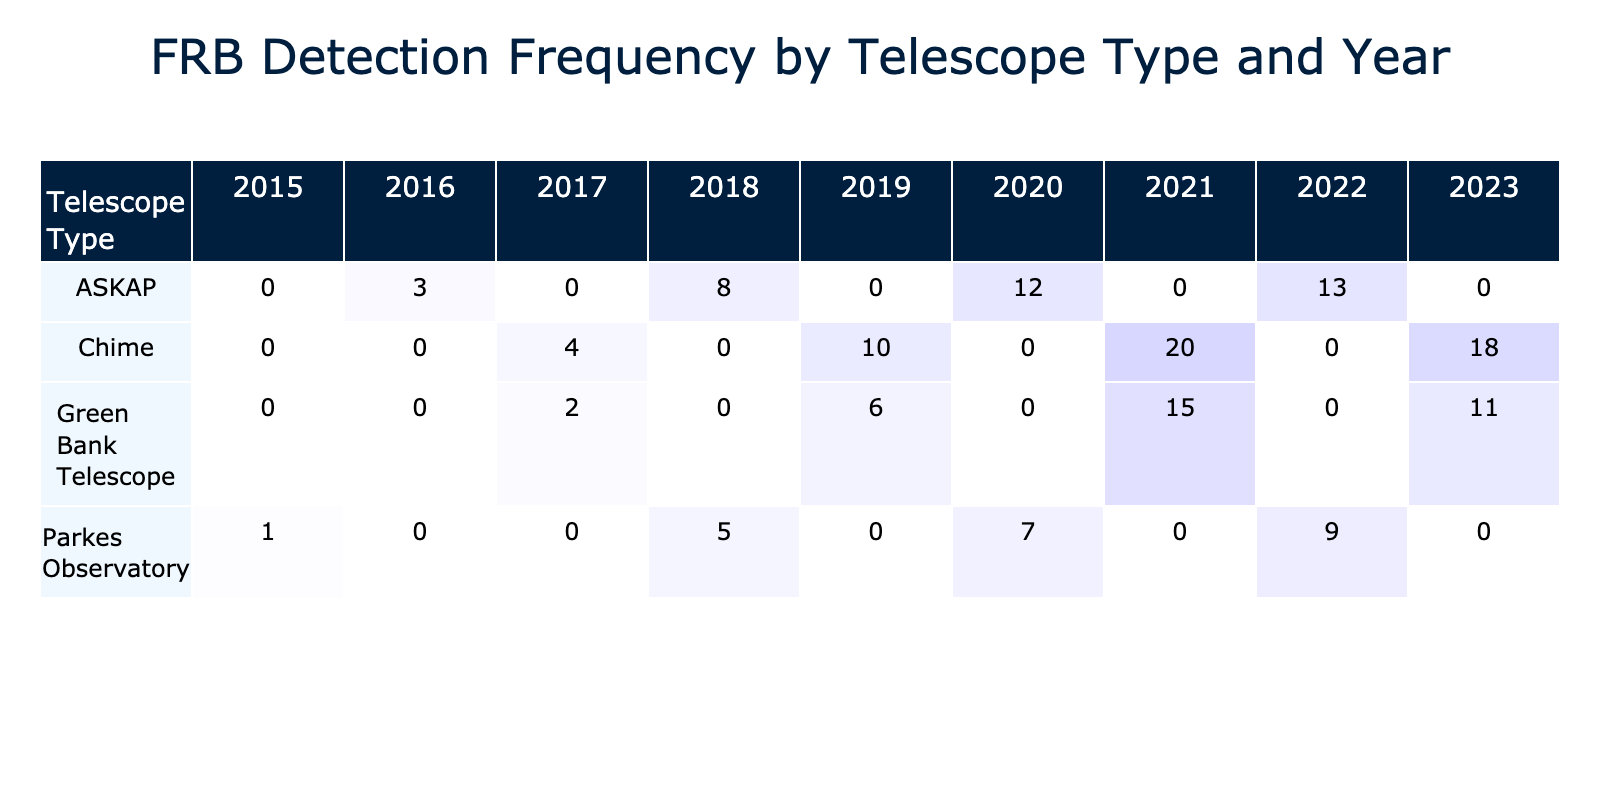What was the highest FRB detection count recorded in 2021? In the year 2021, the highest FRB detection count is noted for the Chime telescope, with a total of 20 detections.
Answer: 20 Which telescope had the lowest total FRB detections across all years? By evaluating the FRB counts for each telescope, the Green Bank Telescope had the lowest total with 2 (in 2017) and 6 (in 2019), summing to 8 detections. Comparing this with others, no telescope has a total lower than this.
Answer: Yes, Green Bank Telescope had the lowest How many FRBs were detected by ASKAP in 2019? Looking specifically at the 2019 column for ASKAP, the FRB detection count shows a total of 0 FRBs. There were no detections recorded for ASKAP in that year.
Answer: 0 What is the total number of FRBs detected by Chime from 2017 to 2023? Adding the counts from Chime from 2017 to 2023: 4 (2017) + 10 (2019) + 20 (2021) + 18 (2023) = 52. The sum of these values yields the total count.
Answer: 52 Did Parkes Observatory detect more FRBs in 2018 compared to 2020? In 2018, Parkes recorded a total of 5 detections, while in 2020, the count was 7. Therefore, Parkes Observatory detected more FRBs in 2020 than in 2018.
Answer: No, 2020 had more detections What is the average FRB detection count for ASKAP from 2016 to 2022? The total detections for ASKAP during these years are: 3 (2016) + 8 (2018) + 12 (2020) + 13 (2022) = 36. There are 4 years, so the average is 36/4 = 9.
Answer: 9 Which telescope type had the highest cumulative FRB detections over the years? Calculating the totals: Parkes (1 + 5 + 7 + 9 = 22), ASKAP (3 + 8 + 12 + 13 = 36), Green Bank (2 + 6 + 15 + 11 = 34), and Chime (4 + 10 + 20 + 18 = 52). The highest cumulative detections are for Chime with 52.
Answer: Chime had the highest cumulative detections Was there any year where the number of FRBs detected dropped compared to the previous year? By examining the yearly totals, we see 2018 to 2019 dropped: Parkes dropped from 5 to 0 (for ASKAP) and Chime dropped from 10 to 0. So yes, there was a drop in both cases.
Answer: Yes, there was a drop What was the overall trend in FRB detections over the years for the Green Bank Telescope? The counts for Green Bank are 2 (2017), 6 (2019), 15 (2021), 11 (2023). The trend shows an increase from 2017 to 2021, but a decrease in 2023. Overall, there's fluctuation but an increasing trend until 2021.
Answer: The overall trend was fluctuating, peaking in 2021 